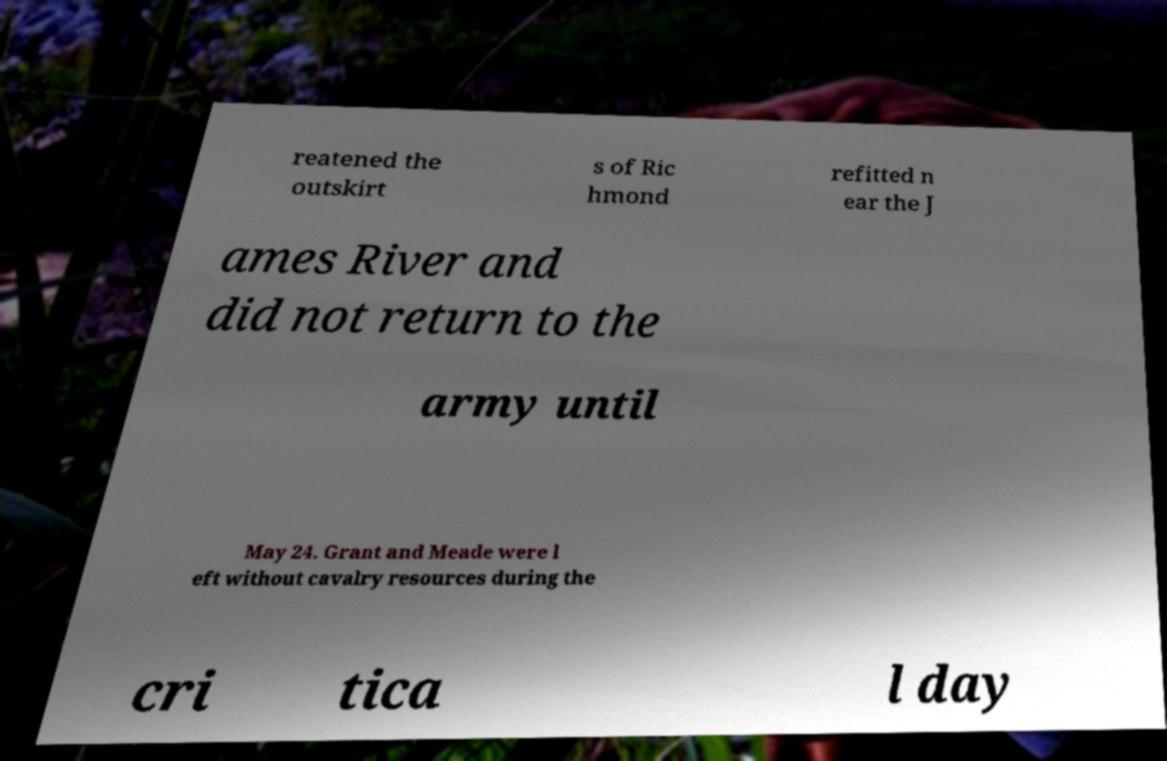Can you accurately transcribe the text from the provided image for me? reatened the outskirt s of Ric hmond refitted n ear the J ames River and did not return to the army until May 24. Grant and Meade were l eft without cavalry resources during the cri tica l day 